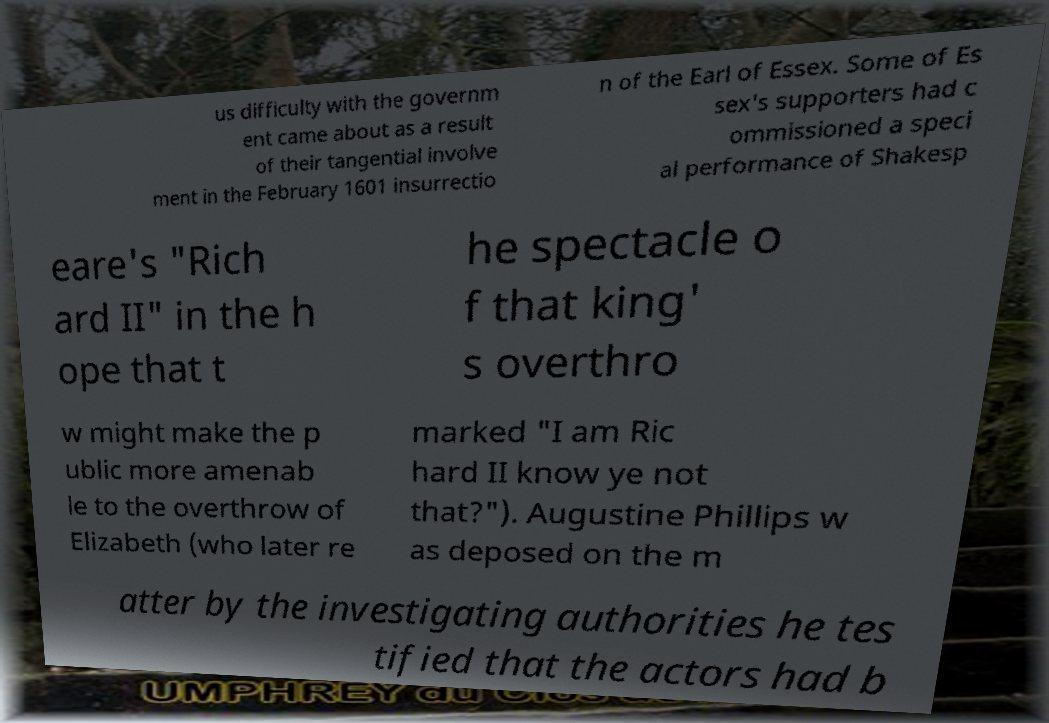There's text embedded in this image that I need extracted. Can you transcribe it verbatim? us difficulty with the governm ent came about as a result of their tangential involve ment in the February 1601 insurrectio n of the Earl of Essex. Some of Es sex's supporters had c ommissioned a speci al performance of Shakesp eare's "Rich ard II" in the h ope that t he spectacle o f that king' s overthro w might make the p ublic more amenab le to the overthrow of Elizabeth (who later re marked "I am Ric hard II know ye not that?"). Augustine Phillips w as deposed on the m atter by the investigating authorities he tes tified that the actors had b 